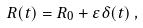<formula> <loc_0><loc_0><loc_500><loc_500>R ( t ) = R _ { 0 } + \varepsilon \delta ( t ) \, ,</formula> 